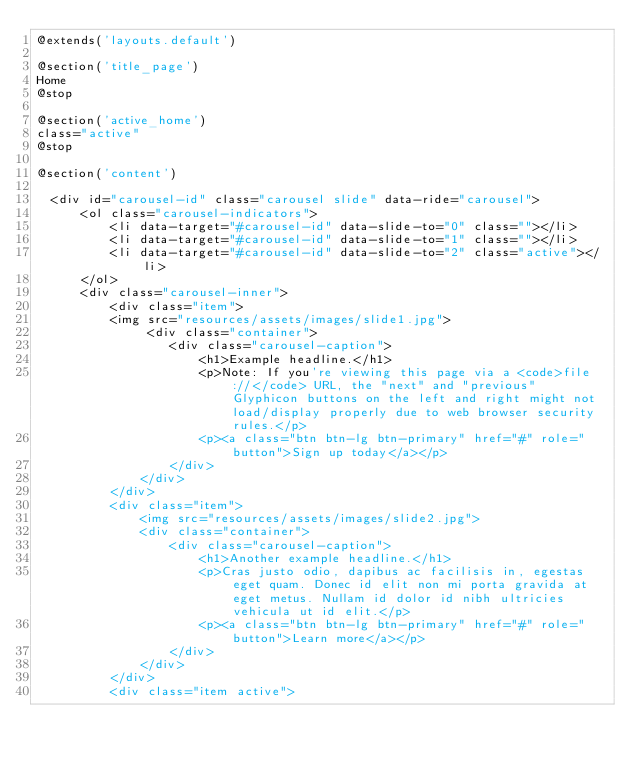Convert code to text. <code><loc_0><loc_0><loc_500><loc_500><_PHP_>@extends('layouts.default')

@section('title_page')
Home
@stop

@section('active_home')
class="active"
@stop

@section('content')

	<div id="carousel-id" class="carousel slide" data-ride="carousel">
	    <ol class="carousel-indicators">
	        <li data-target="#carousel-id" data-slide-to="0" class=""></li>
	        <li data-target="#carousel-id" data-slide-to="1" class=""></li>
	        <li data-target="#carousel-id" data-slide-to="2" class="active"></li>
	    </ol>
	    <div class="carousel-inner">
	        <div class="item">
	       	<img src="resources/assets/images/slide1.jpg">
	             <div class="container">
	                <div class="carousel-caption">
	                    <h1>Example headline.</h1>
	                    <p>Note: If you're viewing this page via a <code>file://</code> URL, the "next" and "previous" Glyphicon buttons on the left and right might not load/display properly due to web browser security rules.</p>
	                    <p><a class="btn btn-lg btn-primary" href="#" role="button">Sign up today</a></p>
	                </div>
	            </div>
	        </div>
	        <div class="item">
	            <img src="resources/assets/images/slide2.jpg">
	            <div class="container">
	                <div class="carousel-caption">
	                    <h1>Another example headline.</h1>
	                    <p>Cras justo odio, dapibus ac facilisis in, egestas eget quam. Donec id elit non mi porta gravida at eget metus. Nullam id dolor id nibh ultricies vehicula ut id elit.</p>
	                    <p><a class="btn btn-lg btn-primary" href="#" role="button">Learn more</a></p>
	                </div>
	            </div>
	        </div>
	        <div class="item active"></code> 